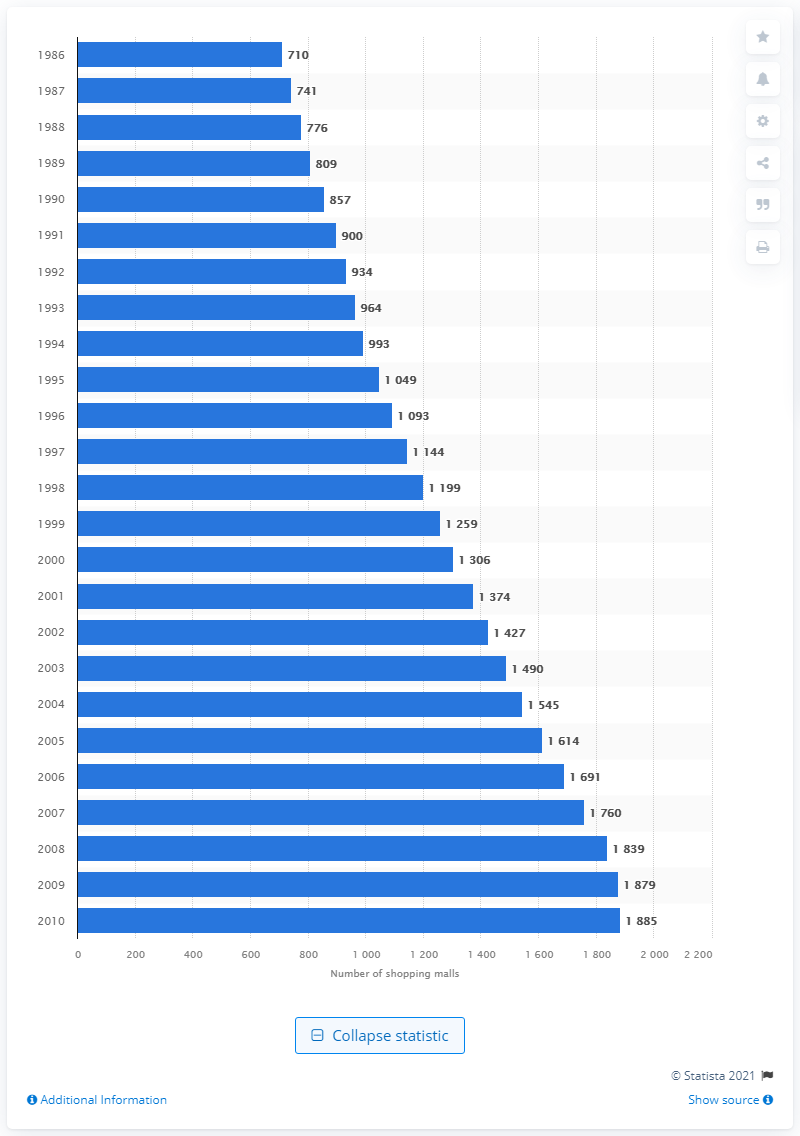List a handful of essential elements in this visual. In 1986, there were 710 shopping malls in the United States. 